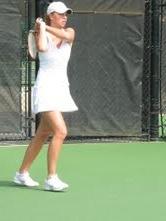What is this person wearing on their head?
Be succinct. Hat. Is this a man?
Answer briefly. No. What does she have in her hands?
Quick response, please. Tennis racket. Are her shirt and skirt the same brand?
Short answer required. Yes. 